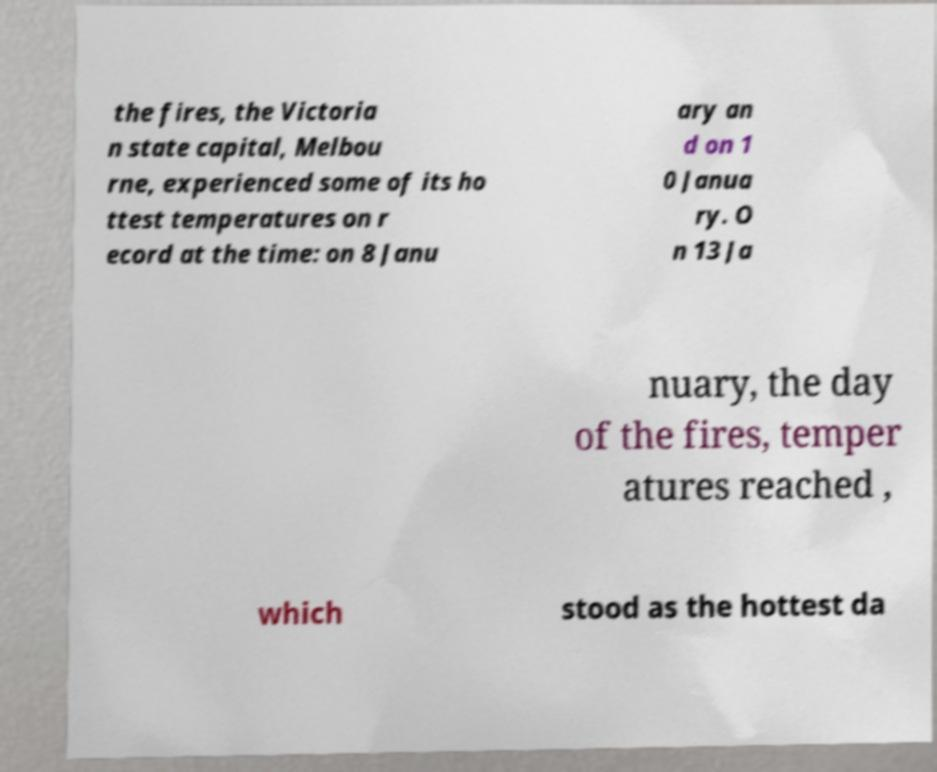Please identify and transcribe the text found in this image. the fires, the Victoria n state capital, Melbou rne, experienced some of its ho ttest temperatures on r ecord at the time: on 8 Janu ary an d on 1 0 Janua ry. O n 13 Ja nuary, the day of the fires, temper atures reached , which stood as the hottest da 